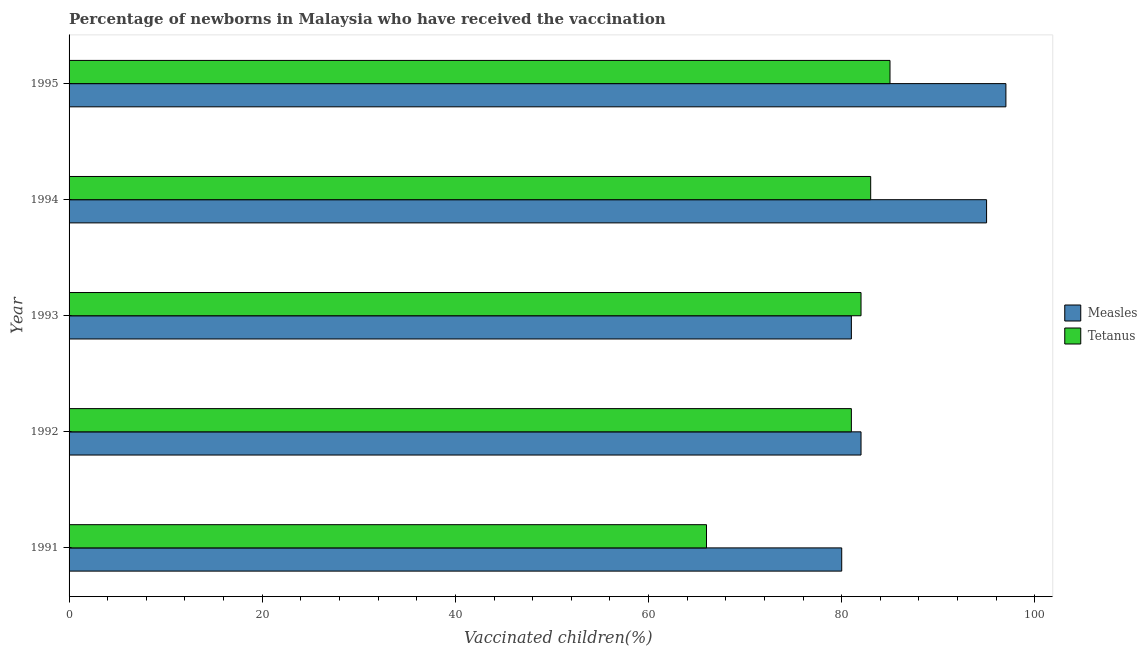How many different coloured bars are there?
Make the answer very short. 2. How many bars are there on the 1st tick from the top?
Keep it short and to the point. 2. How many bars are there on the 4th tick from the bottom?
Provide a succinct answer. 2. In how many cases, is the number of bars for a given year not equal to the number of legend labels?
Give a very brief answer. 0. What is the percentage of newborns who received vaccination for tetanus in 1992?
Ensure brevity in your answer.  81. Across all years, what is the maximum percentage of newborns who received vaccination for tetanus?
Your answer should be compact. 85. Across all years, what is the minimum percentage of newborns who received vaccination for tetanus?
Make the answer very short. 66. What is the total percentage of newborns who received vaccination for measles in the graph?
Your answer should be very brief. 435. What is the difference between the percentage of newborns who received vaccination for measles in 1992 and that in 1993?
Your response must be concise. 1. What is the difference between the percentage of newborns who received vaccination for measles in 1992 and the percentage of newborns who received vaccination for tetanus in 1993?
Provide a short and direct response. 0. What is the average percentage of newborns who received vaccination for measles per year?
Your answer should be compact. 87. In the year 1995, what is the difference between the percentage of newborns who received vaccination for measles and percentage of newborns who received vaccination for tetanus?
Ensure brevity in your answer.  12. In how many years, is the percentage of newborns who received vaccination for tetanus greater than 60 %?
Ensure brevity in your answer.  5. Is the percentage of newborns who received vaccination for tetanus in 1994 less than that in 1995?
Ensure brevity in your answer.  Yes. Is the difference between the percentage of newborns who received vaccination for measles in 1992 and 1993 greater than the difference between the percentage of newborns who received vaccination for tetanus in 1992 and 1993?
Keep it short and to the point. Yes. What is the difference between the highest and the second highest percentage of newborns who received vaccination for tetanus?
Your answer should be compact. 2. What is the difference between the highest and the lowest percentage of newborns who received vaccination for measles?
Ensure brevity in your answer.  17. In how many years, is the percentage of newborns who received vaccination for tetanus greater than the average percentage of newborns who received vaccination for tetanus taken over all years?
Provide a succinct answer. 4. What does the 2nd bar from the top in 1992 represents?
Your response must be concise. Measles. What does the 2nd bar from the bottom in 1993 represents?
Provide a succinct answer. Tetanus. How many bars are there?
Give a very brief answer. 10. Are all the bars in the graph horizontal?
Provide a short and direct response. Yes. What is the difference between two consecutive major ticks on the X-axis?
Your answer should be very brief. 20. Does the graph contain grids?
Give a very brief answer. No. Where does the legend appear in the graph?
Offer a terse response. Center right. How are the legend labels stacked?
Your answer should be compact. Vertical. What is the title of the graph?
Your response must be concise. Percentage of newborns in Malaysia who have received the vaccination. What is the label or title of the X-axis?
Your answer should be compact. Vaccinated children(%)
. What is the Vaccinated children(%)
 in Measles in 1991?
Offer a very short reply. 80. What is the Vaccinated children(%)
 in Measles in 1992?
Ensure brevity in your answer.  82. What is the Vaccinated children(%)
 of Measles in 1993?
Your answer should be very brief. 81. What is the Vaccinated children(%)
 in Measles in 1994?
Provide a short and direct response. 95. What is the Vaccinated children(%)
 of Tetanus in 1994?
Your answer should be very brief. 83. What is the Vaccinated children(%)
 in Measles in 1995?
Ensure brevity in your answer.  97. Across all years, what is the maximum Vaccinated children(%)
 of Measles?
Your response must be concise. 97. Across all years, what is the minimum Vaccinated children(%)
 of Tetanus?
Your answer should be very brief. 66. What is the total Vaccinated children(%)
 of Measles in the graph?
Your answer should be very brief. 435. What is the total Vaccinated children(%)
 in Tetanus in the graph?
Your response must be concise. 397. What is the difference between the Vaccinated children(%)
 of Measles in 1991 and that in 1993?
Provide a short and direct response. -1. What is the difference between the Vaccinated children(%)
 of Tetanus in 1991 and that in 1993?
Your answer should be compact. -16. What is the difference between the Vaccinated children(%)
 in Measles in 1991 and that in 1994?
Your answer should be very brief. -15. What is the difference between the Vaccinated children(%)
 of Measles in 1991 and that in 1995?
Your response must be concise. -17. What is the difference between the Vaccinated children(%)
 in Tetanus in 1991 and that in 1995?
Offer a terse response. -19. What is the difference between the Vaccinated children(%)
 in Tetanus in 1993 and that in 1994?
Your answer should be very brief. -1. What is the difference between the Vaccinated children(%)
 of Measles in 1993 and that in 1995?
Ensure brevity in your answer.  -16. What is the difference between the Vaccinated children(%)
 in Measles in 1994 and that in 1995?
Offer a very short reply. -2. What is the difference between the Vaccinated children(%)
 in Tetanus in 1994 and that in 1995?
Your answer should be compact. -2. What is the difference between the Vaccinated children(%)
 in Measles in 1991 and the Vaccinated children(%)
 in Tetanus in 1992?
Give a very brief answer. -1. What is the difference between the Vaccinated children(%)
 in Measles in 1991 and the Vaccinated children(%)
 in Tetanus in 1993?
Ensure brevity in your answer.  -2. What is the difference between the Vaccinated children(%)
 of Measles in 1991 and the Vaccinated children(%)
 of Tetanus in 1995?
Give a very brief answer. -5. What is the difference between the Vaccinated children(%)
 of Measles in 1992 and the Vaccinated children(%)
 of Tetanus in 1993?
Offer a terse response. 0. What is the difference between the Vaccinated children(%)
 in Measles in 1992 and the Vaccinated children(%)
 in Tetanus in 1995?
Keep it short and to the point. -3. What is the difference between the Vaccinated children(%)
 of Measles in 1993 and the Vaccinated children(%)
 of Tetanus in 1995?
Provide a succinct answer. -4. What is the difference between the Vaccinated children(%)
 of Measles in 1994 and the Vaccinated children(%)
 of Tetanus in 1995?
Offer a terse response. 10. What is the average Vaccinated children(%)
 of Measles per year?
Your response must be concise. 87. What is the average Vaccinated children(%)
 in Tetanus per year?
Provide a short and direct response. 79.4. In the year 1994, what is the difference between the Vaccinated children(%)
 in Measles and Vaccinated children(%)
 in Tetanus?
Offer a terse response. 12. In the year 1995, what is the difference between the Vaccinated children(%)
 in Measles and Vaccinated children(%)
 in Tetanus?
Offer a very short reply. 12. What is the ratio of the Vaccinated children(%)
 of Measles in 1991 to that in 1992?
Your answer should be compact. 0.98. What is the ratio of the Vaccinated children(%)
 of Tetanus in 1991 to that in 1992?
Offer a terse response. 0.81. What is the ratio of the Vaccinated children(%)
 in Tetanus in 1991 to that in 1993?
Ensure brevity in your answer.  0.8. What is the ratio of the Vaccinated children(%)
 of Measles in 1991 to that in 1994?
Your response must be concise. 0.84. What is the ratio of the Vaccinated children(%)
 of Tetanus in 1991 to that in 1994?
Provide a succinct answer. 0.8. What is the ratio of the Vaccinated children(%)
 in Measles in 1991 to that in 1995?
Your answer should be very brief. 0.82. What is the ratio of the Vaccinated children(%)
 of Tetanus in 1991 to that in 1995?
Make the answer very short. 0.78. What is the ratio of the Vaccinated children(%)
 in Measles in 1992 to that in 1993?
Keep it short and to the point. 1.01. What is the ratio of the Vaccinated children(%)
 in Tetanus in 1992 to that in 1993?
Keep it short and to the point. 0.99. What is the ratio of the Vaccinated children(%)
 in Measles in 1992 to that in 1994?
Offer a very short reply. 0.86. What is the ratio of the Vaccinated children(%)
 in Tetanus in 1992 to that in 1994?
Offer a terse response. 0.98. What is the ratio of the Vaccinated children(%)
 of Measles in 1992 to that in 1995?
Offer a terse response. 0.85. What is the ratio of the Vaccinated children(%)
 of Tetanus in 1992 to that in 1995?
Your response must be concise. 0.95. What is the ratio of the Vaccinated children(%)
 of Measles in 1993 to that in 1994?
Your answer should be compact. 0.85. What is the ratio of the Vaccinated children(%)
 in Tetanus in 1993 to that in 1994?
Your answer should be compact. 0.99. What is the ratio of the Vaccinated children(%)
 of Measles in 1993 to that in 1995?
Your answer should be very brief. 0.84. What is the ratio of the Vaccinated children(%)
 of Tetanus in 1993 to that in 1995?
Ensure brevity in your answer.  0.96. What is the ratio of the Vaccinated children(%)
 in Measles in 1994 to that in 1995?
Your answer should be compact. 0.98. What is the ratio of the Vaccinated children(%)
 in Tetanus in 1994 to that in 1995?
Make the answer very short. 0.98. What is the difference between the highest and the second highest Vaccinated children(%)
 in Measles?
Ensure brevity in your answer.  2. What is the difference between the highest and the second highest Vaccinated children(%)
 of Tetanus?
Provide a succinct answer. 2. 